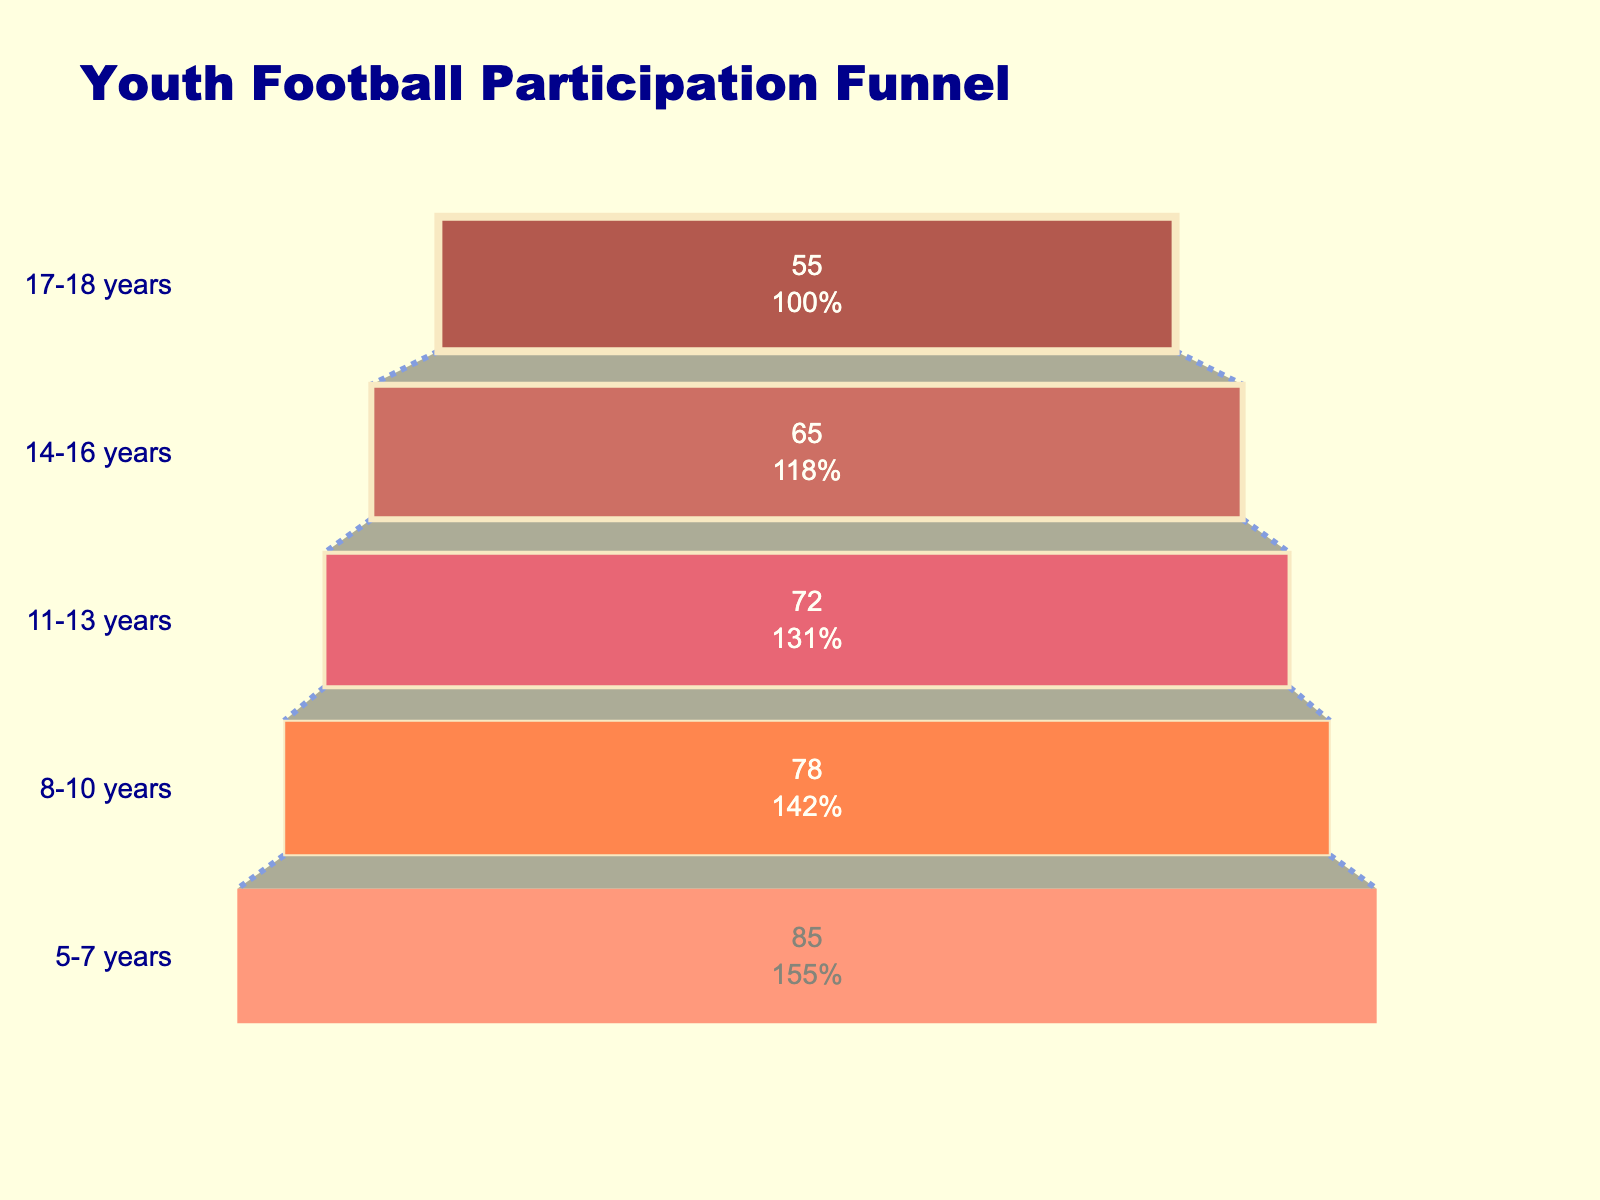How many age groups are displayed in the funnel chart? The funnel chart shows separate bands for each age group. To find the total number of age groups, count the bands.
Answer: 5 What is the participation rate for the 11-13 years age group? Locate the section of the funnel chart that corresponds to 11-13 years, and note the participation rate listed inside that band.
Answer: 72% Which age group has the highest participation rate? Look at the top-most band of the funnel chart, which represents the age group with the highest participation rate.
Answer: 5-7 years What is the difference in participation rates between the 14-16 years and 17-18 years age groups? Identify the participation rates for both 14-16 years (65%) and 17-18 years (55%). Subtract the lower rate from the higher rate (65% - 55%).
Answer: 10% What percentage of participants are lost when moving from the 5-7 years age group to the 8-10 years age group? Identify the participation rates for both 5-7 years (85%) and 8-10 years (78%). Calculate the percentage decrease by subtracting 78 from 85, then divide the difference by 85 and multiply by 100.
Answer: 8.24% What is the overall trend in participation rates as age increases? Examine the funnel chart from top to bottom. Note the decline in participation rates as age groups advance from 5-7 years to 17-18 years.
Answer: Decreasing trend How much lower is the participation rate for the 17-18 years age group compared to the 5-7 years age group? Find the participation rates for the 17-18 years (55%) and 5-7 years (85%), then subtract the 17-18 rate from the 5-7 rate (85% - 55%).
Answer: 30% Which age group shows a greater decline in participation rates compared to the previous age group, 8-10 years to 11-13 years or 11-13 years to 14-16 years? Calculate the decline between 8-10 years (78%) to 11-13 years (72%) and between 11-13 years (72%) to 14-16 years (65%) and compare the declines (6% vs. 7%).
Answer: 11-13 years to 14-16 years What is the participation rate of the second-highest age group? Identify the second-highest band from the top of the funnel chart, which represents 8-10 years, and note the participation rate.
Answer: 78% What color is used for the age group with the lowest participation rate? The funnel chart uses different colors for each age group. Identify the color for the lowest band, which represents 17-18 years.
Answer: Coral 